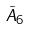Convert formula to latex. <formula><loc_0><loc_0><loc_500><loc_500>\tilde { A } _ { 6 }</formula> 